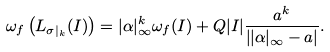<formula> <loc_0><loc_0><loc_500><loc_500>\omega _ { f } \left ( L _ { \sigma | _ { k } } ( I ) \right ) = | \alpha | _ { \infty } ^ { k } \omega _ { f } ( I ) + Q | I | \frac { a ^ { k } } { \left | | \alpha | _ { \infty } - a \right | } .</formula> 